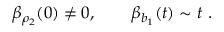Convert formula to latex. <formula><loc_0><loc_0><loc_500><loc_500>\beta _ { \rho _ { 2 } } ( 0 ) \not = 0 , \quad \beta _ { b _ { 1 } } ( t ) \sim t \ .</formula> 